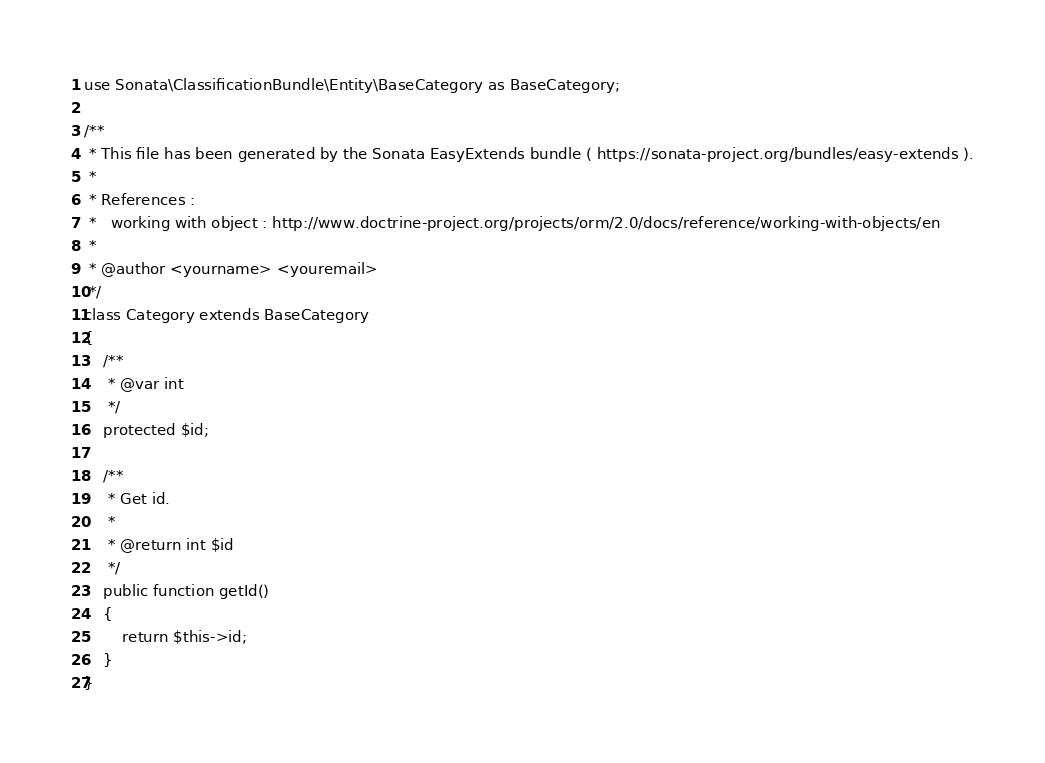Convert code to text. <code><loc_0><loc_0><loc_500><loc_500><_PHP_>
use Sonata\ClassificationBundle\Entity\BaseCategory as BaseCategory;

/**
 * This file has been generated by the Sonata EasyExtends bundle ( https://sonata-project.org/bundles/easy-extends ).
 *
 * References :
 *   working with object : http://www.doctrine-project.org/projects/orm/2.0/docs/reference/working-with-objects/en
 *
 * @author <yourname> <youremail>
 */
class Category extends BaseCategory
{
    /**
     * @var int
     */
    protected $id;

    /**
     * Get id.
     *
     * @return int $id
     */
    public function getId()
    {
        return $this->id;
    }
}
</code> 